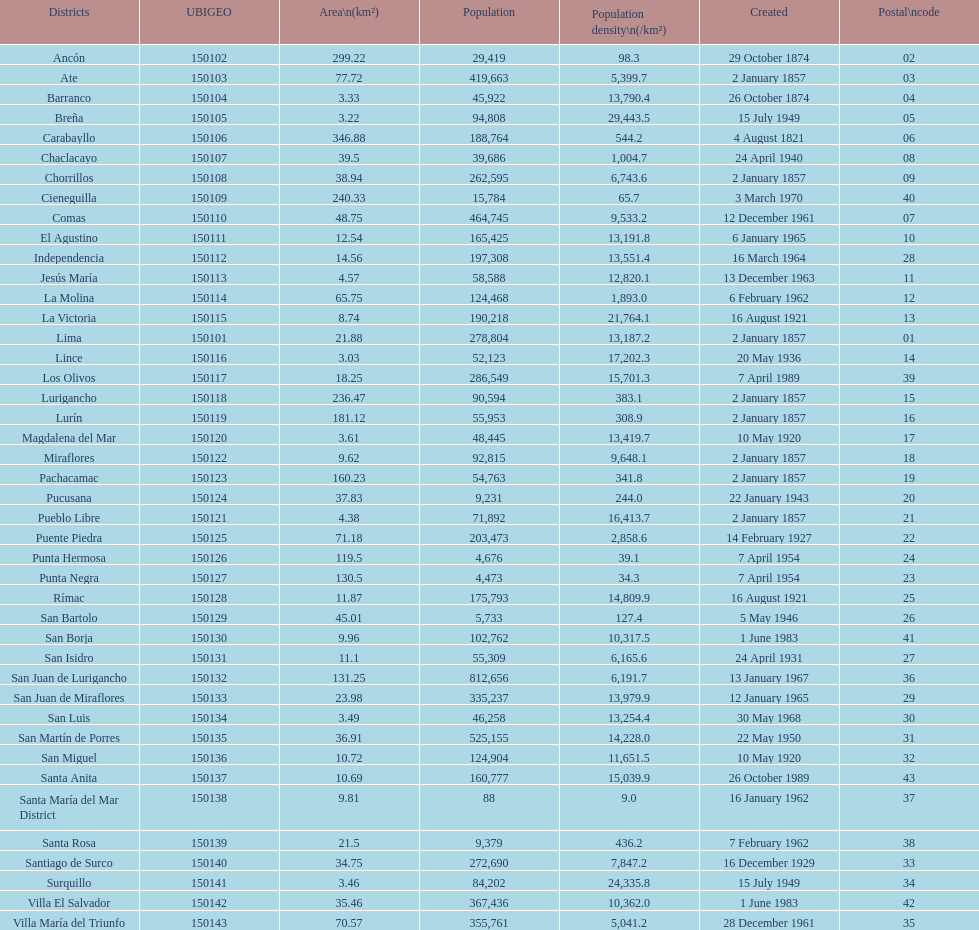0? 31. 